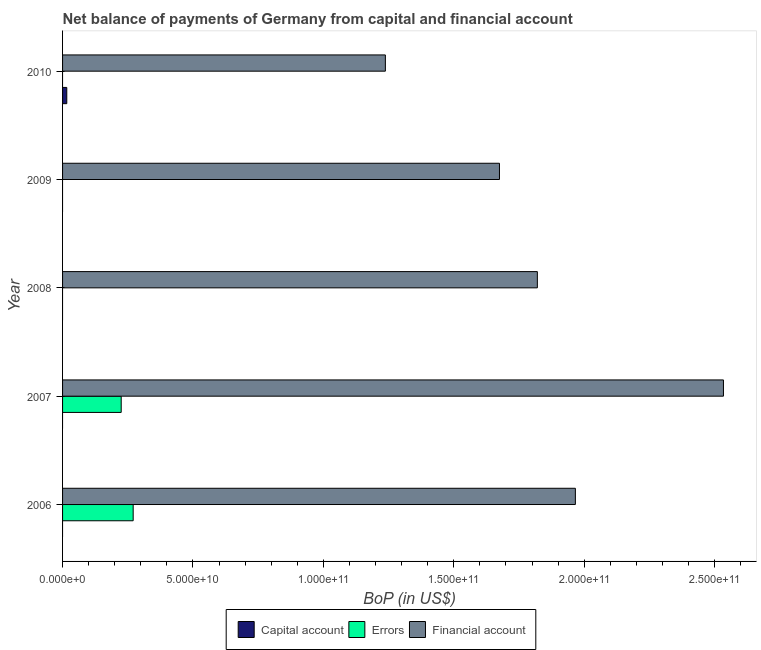How many different coloured bars are there?
Provide a short and direct response. 3. Are the number of bars on each tick of the Y-axis equal?
Make the answer very short. No. How many bars are there on the 4th tick from the bottom?
Your response must be concise. 1. What is the label of the 4th group of bars from the top?
Give a very brief answer. 2007. In how many cases, is the number of bars for a given year not equal to the number of legend labels?
Your answer should be very brief. 5. Across all years, what is the maximum amount of financial account?
Your response must be concise. 2.53e+11. Across all years, what is the minimum amount of net capital account?
Your answer should be very brief. 0. What is the total amount of financial account in the graph?
Give a very brief answer. 9.23e+11. What is the difference between the amount of financial account in 2006 and that in 2009?
Provide a short and direct response. 2.91e+1. What is the difference between the amount of errors in 2007 and the amount of financial account in 2010?
Your answer should be compact. -1.01e+11. What is the average amount of net capital account per year?
Your response must be concise. 3.23e+08. In the year 2007, what is the difference between the amount of errors and amount of financial account?
Provide a short and direct response. -2.31e+11. What is the ratio of the amount of financial account in 2007 to that in 2009?
Provide a short and direct response. 1.51. Is the amount of financial account in 2006 less than that in 2007?
Ensure brevity in your answer.  Yes. Is the difference between the amount of errors in 2006 and 2007 greater than the difference between the amount of financial account in 2006 and 2007?
Make the answer very short. Yes. What is the difference between the highest and the second highest amount of financial account?
Make the answer very short. 5.68e+1. What is the difference between the highest and the lowest amount of net capital account?
Provide a succinct answer. 1.62e+09. In how many years, is the amount of net capital account greater than the average amount of net capital account taken over all years?
Make the answer very short. 1. Is the sum of the amount of financial account in 2006 and 2009 greater than the maximum amount of errors across all years?
Make the answer very short. Yes. How many bars are there?
Offer a terse response. 8. Does the graph contain grids?
Your answer should be compact. No. How are the legend labels stacked?
Your response must be concise. Horizontal. What is the title of the graph?
Your answer should be compact. Net balance of payments of Germany from capital and financial account. Does "ICT services" appear as one of the legend labels in the graph?
Give a very brief answer. No. What is the label or title of the X-axis?
Keep it short and to the point. BoP (in US$). What is the BoP (in US$) of Capital account in 2006?
Make the answer very short. 0. What is the BoP (in US$) of Errors in 2006?
Your response must be concise. 2.71e+1. What is the BoP (in US$) in Financial account in 2006?
Offer a very short reply. 1.97e+11. What is the BoP (in US$) in Errors in 2007?
Ensure brevity in your answer.  2.25e+1. What is the BoP (in US$) of Financial account in 2007?
Keep it short and to the point. 2.53e+11. What is the BoP (in US$) in Capital account in 2008?
Give a very brief answer. 0. What is the BoP (in US$) of Financial account in 2008?
Your answer should be very brief. 1.82e+11. What is the BoP (in US$) of Errors in 2009?
Give a very brief answer. 0. What is the BoP (in US$) in Financial account in 2009?
Offer a terse response. 1.68e+11. What is the BoP (in US$) in Capital account in 2010?
Provide a short and direct response. 1.62e+09. What is the BoP (in US$) in Errors in 2010?
Your answer should be very brief. 0. What is the BoP (in US$) in Financial account in 2010?
Keep it short and to the point. 1.24e+11. Across all years, what is the maximum BoP (in US$) in Capital account?
Keep it short and to the point. 1.62e+09. Across all years, what is the maximum BoP (in US$) of Errors?
Ensure brevity in your answer.  2.71e+1. Across all years, what is the maximum BoP (in US$) in Financial account?
Provide a short and direct response. 2.53e+11. Across all years, what is the minimum BoP (in US$) of Financial account?
Make the answer very short. 1.24e+11. What is the total BoP (in US$) of Capital account in the graph?
Your answer should be very brief. 1.62e+09. What is the total BoP (in US$) of Errors in the graph?
Your answer should be compact. 4.96e+1. What is the total BoP (in US$) in Financial account in the graph?
Provide a succinct answer. 9.23e+11. What is the difference between the BoP (in US$) in Errors in 2006 and that in 2007?
Provide a short and direct response. 4.58e+09. What is the difference between the BoP (in US$) of Financial account in 2006 and that in 2007?
Keep it short and to the point. -5.68e+1. What is the difference between the BoP (in US$) in Financial account in 2006 and that in 2008?
Your answer should be very brief. 1.46e+1. What is the difference between the BoP (in US$) of Financial account in 2006 and that in 2009?
Provide a short and direct response. 2.91e+1. What is the difference between the BoP (in US$) in Financial account in 2006 and that in 2010?
Give a very brief answer. 7.28e+1. What is the difference between the BoP (in US$) of Financial account in 2007 and that in 2008?
Make the answer very short. 7.13e+1. What is the difference between the BoP (in US$) of Financial account in 2007 and that in 2009?
Offer a very short reply. 8.59e+1. What is the difference between the BoP (in US$) in Financial account in 2007 and that in 2010?
Provide a succinct answer. 1.30e+11. What is the difference between the BoP (in US$) of Financial account in 2008 and that in 2009?
Your answer should be very brief. 1.45e+1. What is the difference between the BoP (in US$) in Financial account in 2008 and that in 2010?
Ensure brevity in your answer.  5.83e+1. What is the difference between the BoP (in US$) in Financial account in 2009 and that in 2010?
Ensure brevity in your answer.  4.37e+1. What is the difference between the BoP (in US$) in Errors in 2006 and the BoP (in US$) in Financial account in 2007?
Offer a terse response. -2.26e+11. What is the difference between the BoP (in US$) of Errors in 2006 and the BoP (in US$) of Financial account in 2008?
Your answer should be compact. -1.55e+11. What is the difference between the BoP (in US$) in Errors in 2006 and the BoP (in US$) in Financial account in 2009?
Offer a terse response. -1.40e+11. What is the difference between the BoP (in US$) of Errors in 2006 and the BoP (in US$) of Financial account in 2010?
Provide a short and direct response. -9.67e+1. What is the difference between the BoP (in US$) in Errors in 2007 and the BoP (in US$) in Financial account in 2008?
Provide a succinct answer. -1.60e+11. What is the difference between the BoP (in US$) in Errors in 2007 and the BoP (in US$) in Financial account in 2009?
Make the answer very short. -1.45e+11. What is the difference between the BoP (in US$) of Errors in 2007 and the BoP (in US$) of Financial account in 2010?
Keep it short and to the point. -1.01e+11. What is the average BoP (in US$) in Capital account per year?
Keep it short and to the point. 3.23e+08. What is the average BoP (in US$) in Errors per year?
Your answer should be compact. 9.91e+09. What is the average BoP (in US$) in Financial account per year?
Your response must be concise. 1.85e+11. In the year 2006, what is the difference between the BoP (in US$) of Errors and BoP (in US$) of Financial account?
Provide a succinct answer. -1.70e+11. In the year 2007, what is the difference between the BoP (in US$) in Errors and BoP (in US$) in Financial account?
Your response must be concise. -2.31e+11. In the year 2010, what is the difference between the BoP (in US$) in Capital account and BoP (in US$) in Financial account?
Provide a short and direct response. -1.22e+11. What is the ratio of the BoP (in US$) of Errors in 2006 to that in 2007?
Provide a short and direct response. 1.2. What is the ratio of the BoP (in US$) in Financial account in 2006 to that in 2007?
Your answer should be compact. 0.78. What is the ratio of the BoP (in US$) of Financial account in 2006 to that in 2008?
Keep it short and to the point. 1.08. What is the ratio of the BoP (in US$) of Financial account in 2006 to that in 2009?
Give a very brief answer. 1.17. What is the ratio of the BoP (in US$) of Financial account in 2006 to that in 2010?
Offer a very short reply. 1.59. What is the ratio of the BoP (in US$) in Financial account in 2007 to that in 2008?
Offer a very short reply. 1.39. What is the ratio of the BoP (in US$) of Financial account in 2007 to that in 2009?
Keep it short and to the point. 1.51. What is the ratio of the BoP (in US$) in Financial account in 2007 to that in 2010?
Your answer should be very brief. 2.05. What is the ratio of the BoP (in US$) in Financial account in 2008 to that in 2009?
Offer a terse response. 1.09. What is the ratio of the BoP (in US$) in Financial account in 2008 to that in 2010?
Offer a very short reply. 1.47. What is the ratio of the BoP (in US$) in Financial account in 2009 to that in 2010?
Provide a short and direct response. 1.35. What is the difference between the highest and the second highest BoP (in US$) in Financial account?
Offer a very short reply. 5.68e+1. What is the difference between the highest and the lowest BoP (in US$) of Capital account?
Keep it short and to the point. 1.62e+09. What is the difference between the highest and the lowest BoP (in US$) in Errors?
Your response must be concise. 2.71e+1. What is the difference between the highest and the lowest BoP (in US$) of Financial account?
Your answer should be very brief. 1.30e+11. 